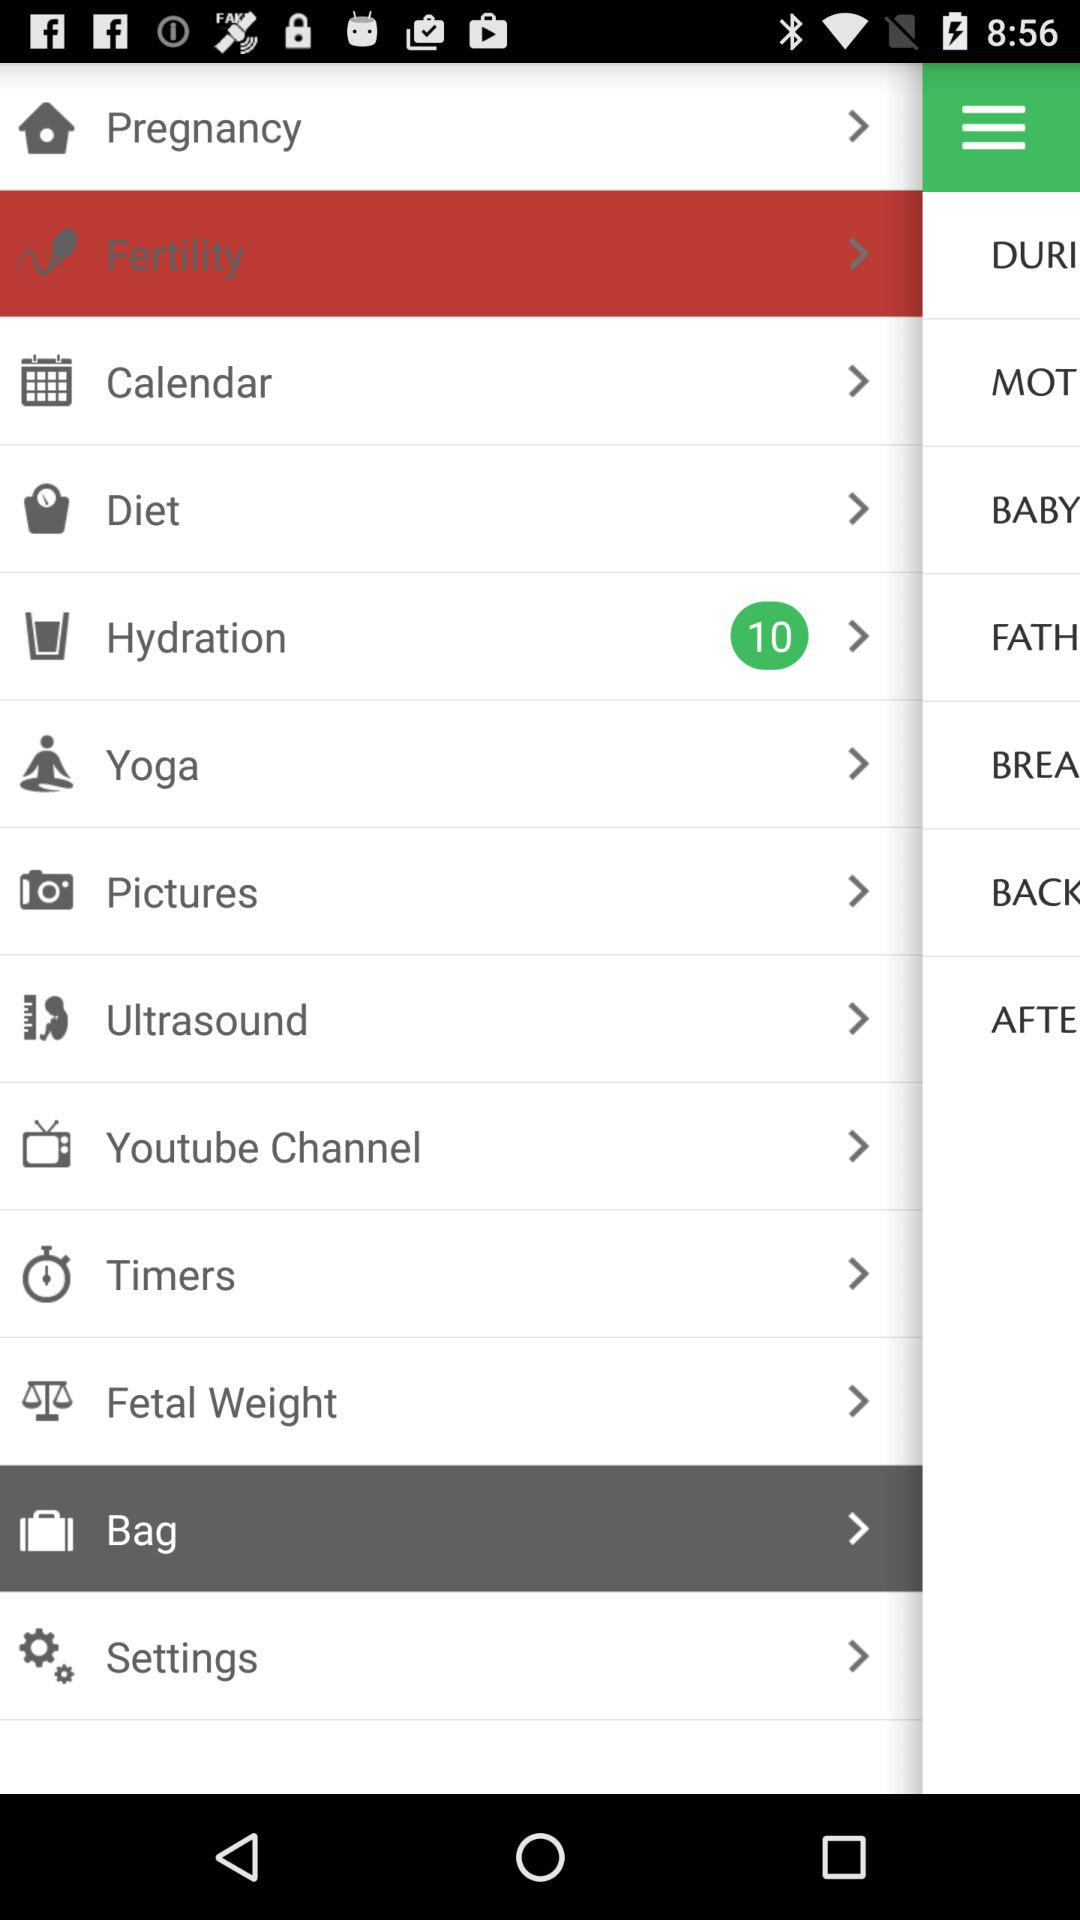How many items are in "Yoga"?
When the provided information is insufficient, respond with <no answer>. <no answer> 